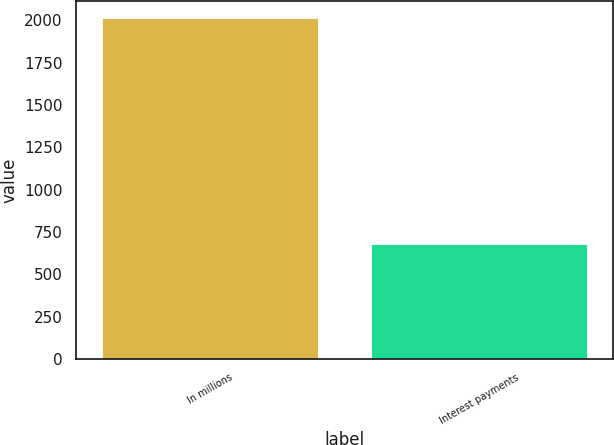Convert chart to OTSL. <chart><loc_0><loc_0><loc_500><loc_500><bar_chart><fcel>In millions<fcel>Interest payments<nl><fcel>2015<fcel>680<nl></chart> 